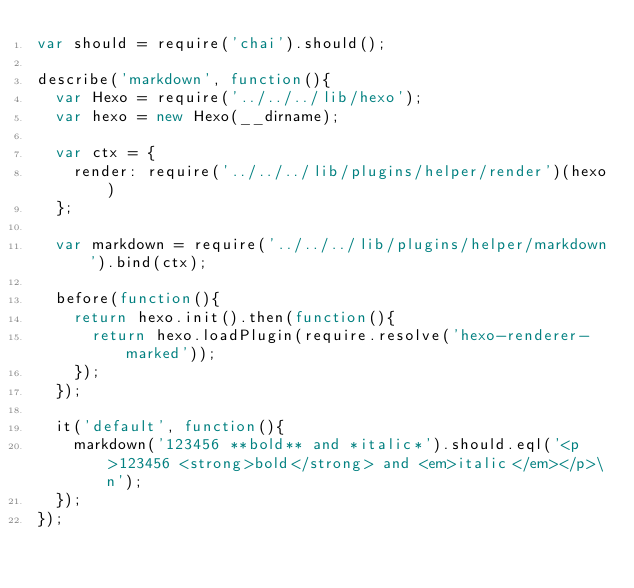<code> <loc_0><loc_0><loc_500><loc_500><_JavaScript_>var should = require('chai').should();

describe('markdown', function(){
  var Hexo = require('../../../lib/hexo');
  var hexo = new Hexo(__dirname);

  var ctx = {
    render: require('../../../lib/plugins/helper/render')(hexo)
  };

  var markdown = require('../../../lib/plugins/helper/markdown').bind(ctx);

  before(function(){
    return hexo.init().then(function(){
      return hexo.loadPlugin(require.resolve('hexo-renderer-marked'));
    });
  });

  it('default', function(){
    markdown('123456 **bold** and *italic*').should.eql('<p>123456 <strong>bold</strong> and <em>italic</em></p>\n');
  });
});</code> 